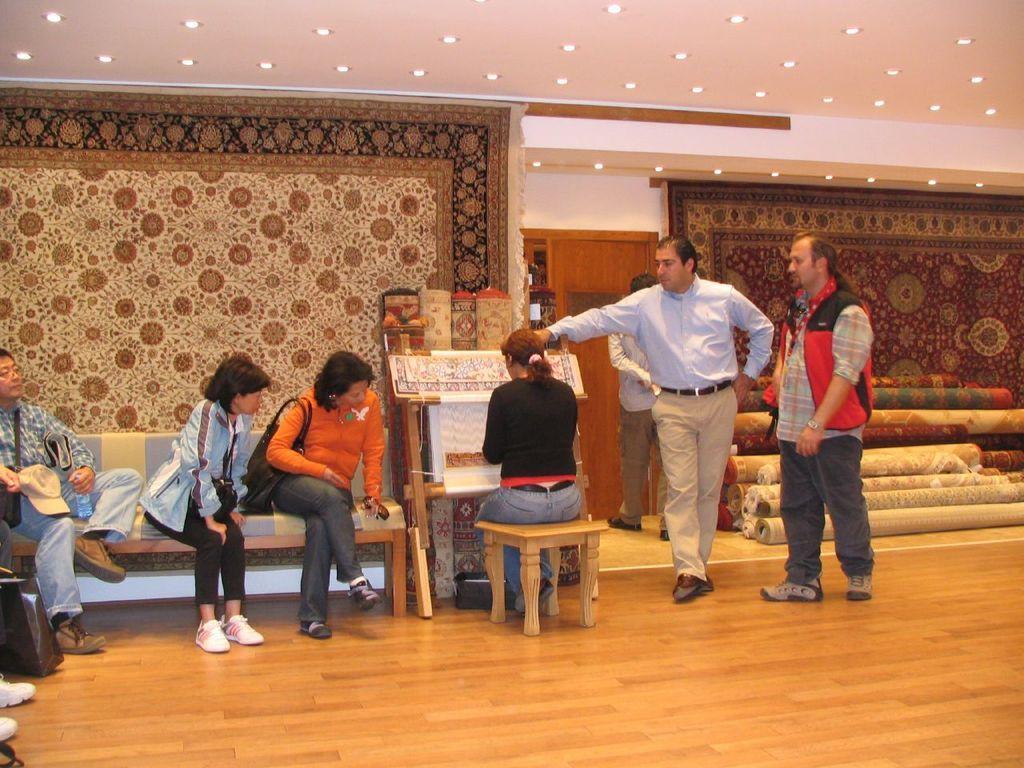Could you give a brief overview of what you see in this image? In this image I can see there are three persons sitting on sofa chair on left side and I can see a woman sitting on small table and in front of the table I can see there are three persons visible on floor at the top I can see roof , on roof I can see lights and in the middle I can see the wall , on the wall I can see a design curtain visible and i can see there are curtains kept on floor on the right side. 